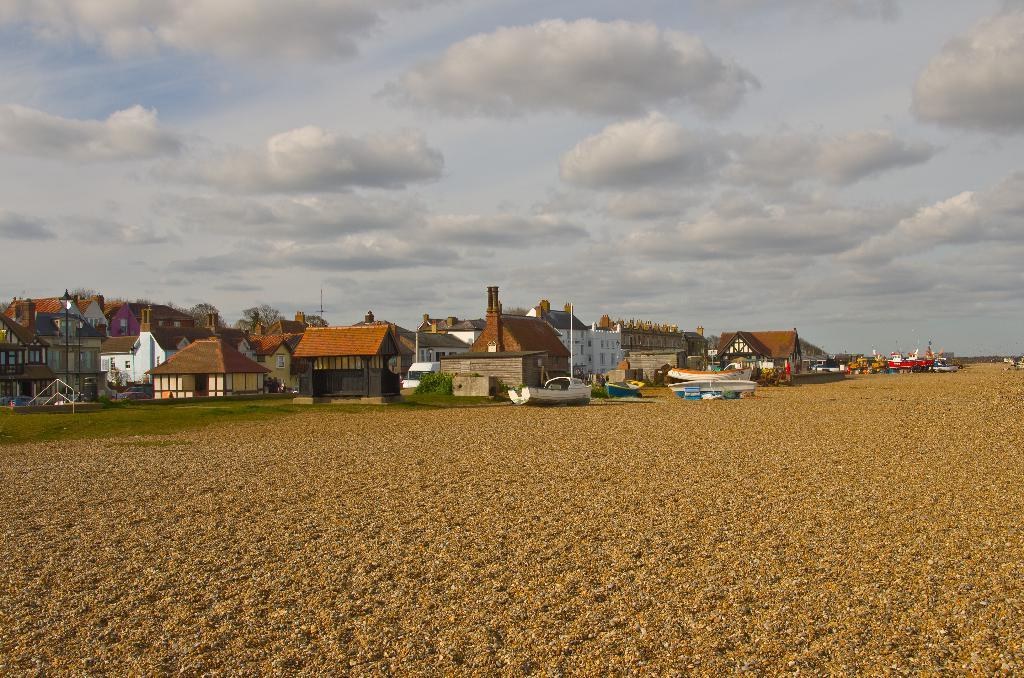What type of vegetation is present in the image? There is grass in the image. What type of structures can be seen in the image? There are houses and buildings in the image. What are the boats doing in the image? The boats are on the ground in the image. What is visible at the top of the image? The sky is visible at the top of the image. Can you describe the possible location of the image? The image may have been taken near a sandy beach. What does the dad say about the cows in the image? There is no dad or cows present in the image. Can you describe how the boats bite into the sand in the image? The boats are not biting into the sand in the image; they are on the ground. 